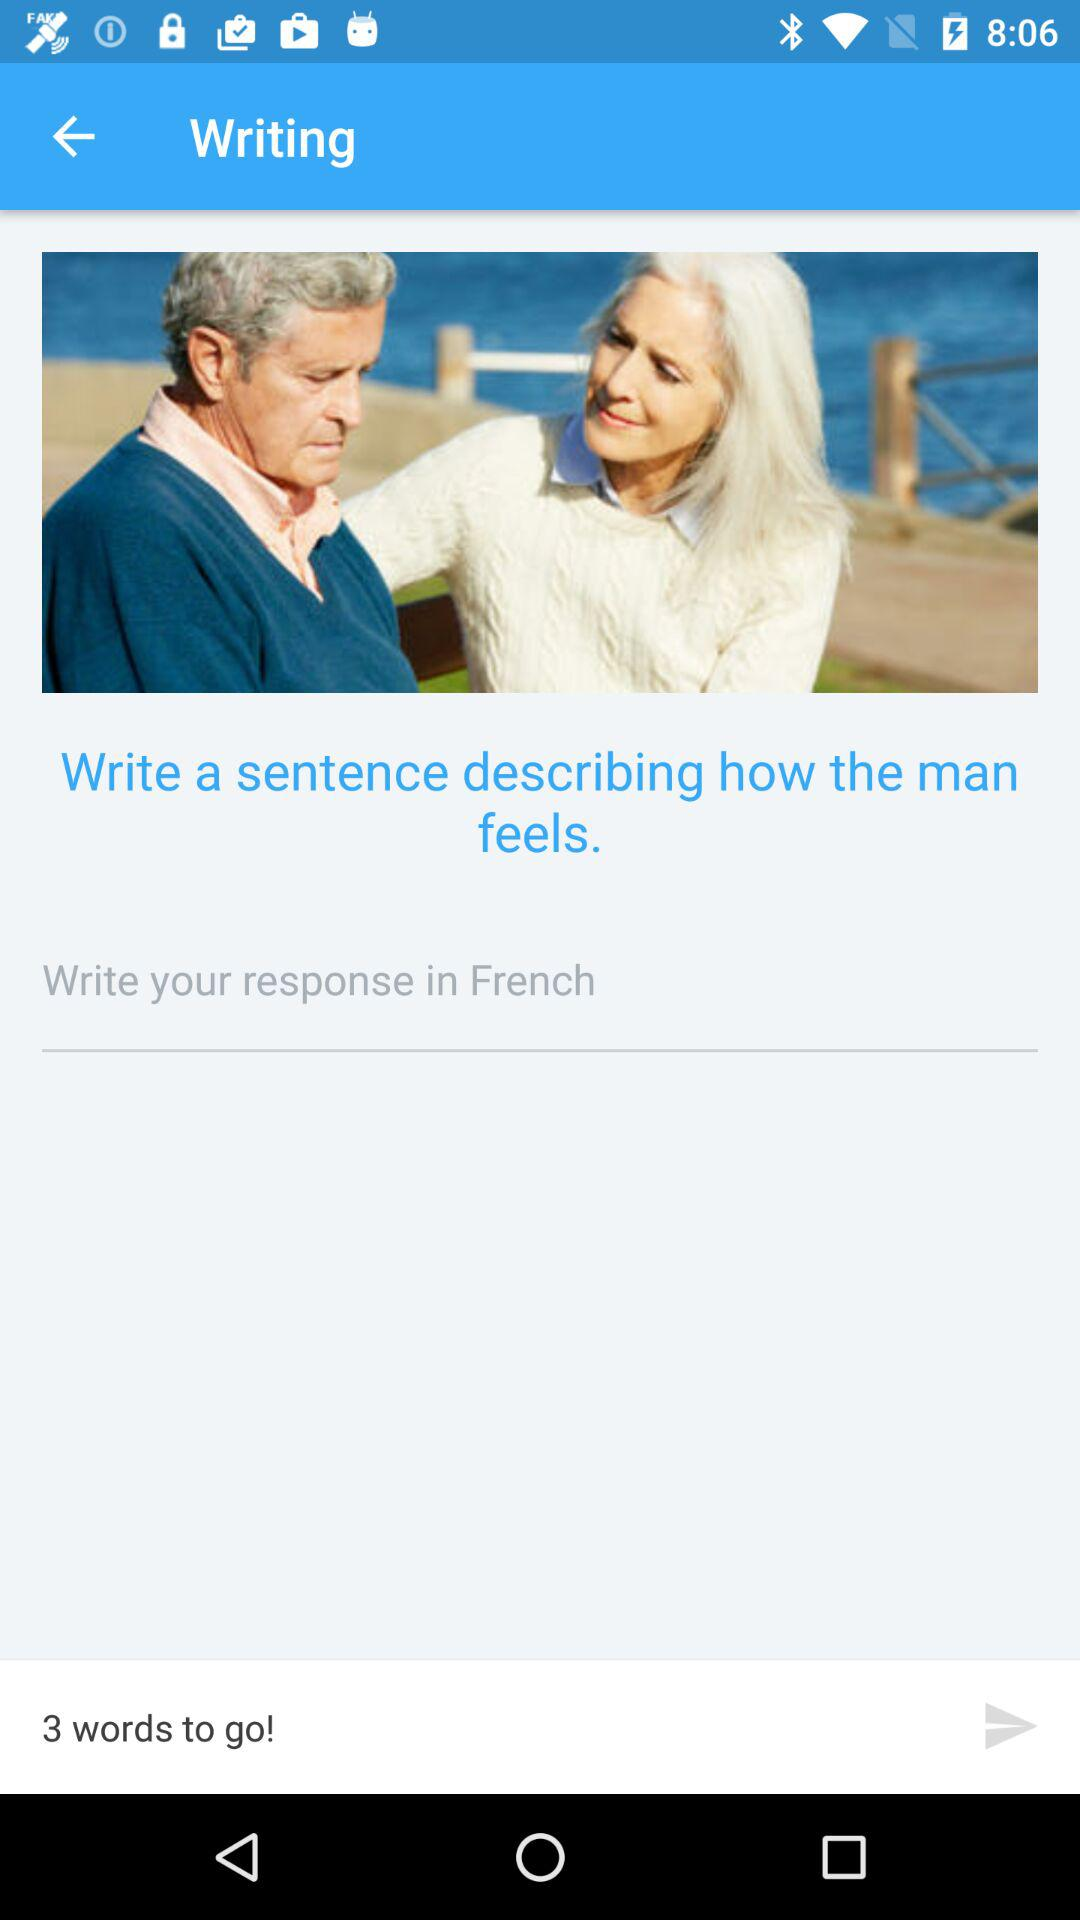How does the man feel?
When the provided information is insufficient, respond with <no answer>. <no answer> 